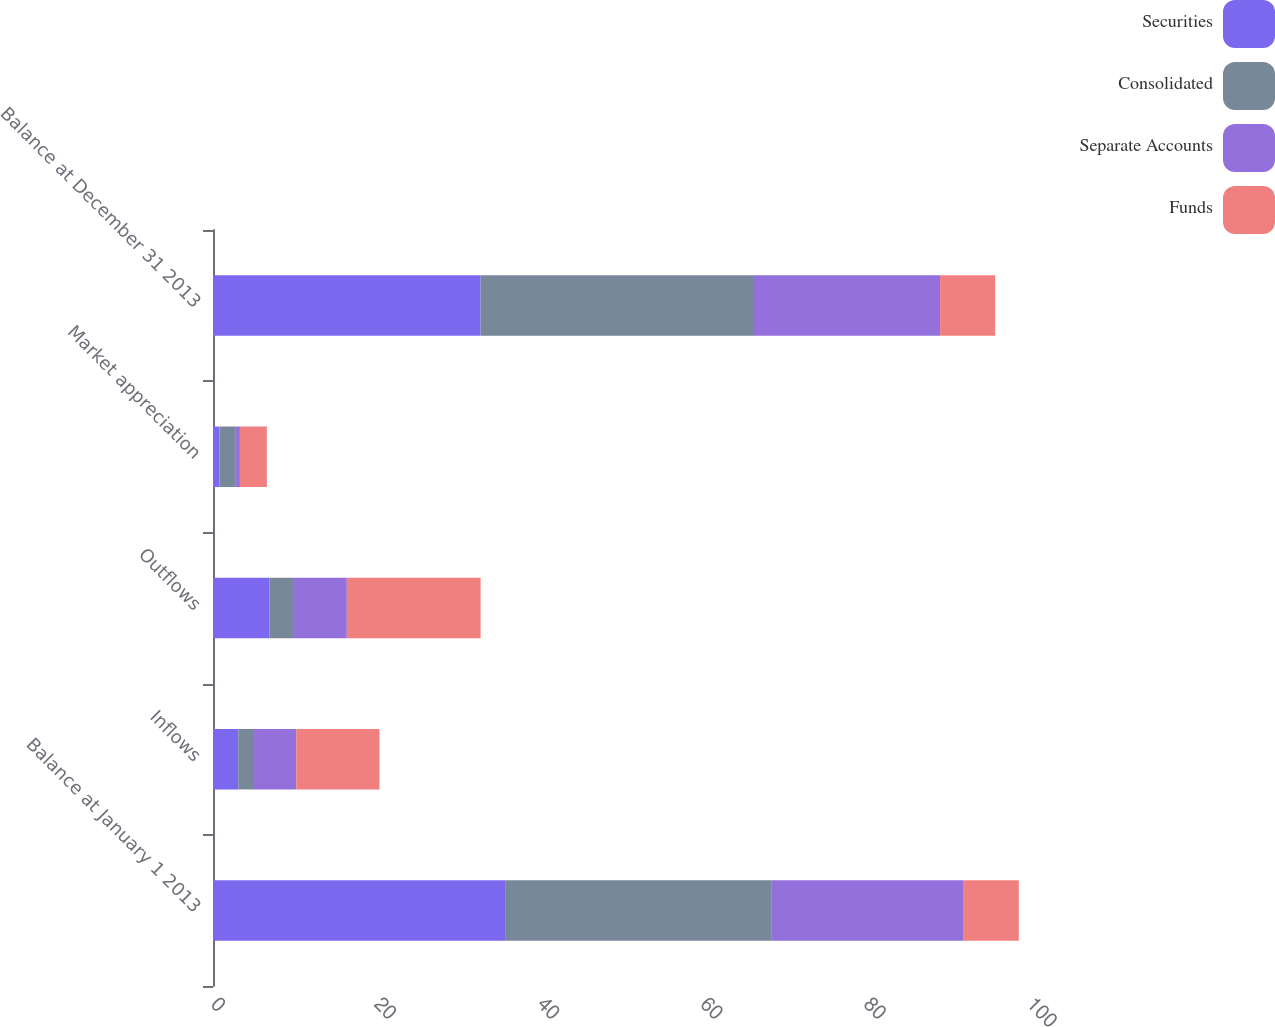Convert chart to OTSL. <chart><loc_0><loc_0><loc_500><loc_500><stacked_bar_chart><ecel><fcel>Balance at January 1 2013<fcel>Inflows<fcel>Outflows<fcel>Market appreciation<fcel>Balance at December 31 2013<nl><fcel>Securities<fcel>35.8<fcel>3.1<fcel>6.9<fcel>0.8<fcel>32.8<nl><fcel>Consolidated<fcel>32.6<fcel>1.8<fcel>2.9<fcel>2<fcel>33.5<nl><fcel>Separate Accounts<fcel>23.6<fcel>5.3<fcel>6.6<fcel>0.5<fcel>22.8<nl><fcel>Funds<fcel>6.75<fcel>10.2<fcel>16.4<fcel>3.3<fcel>6.75<nl></chart> 